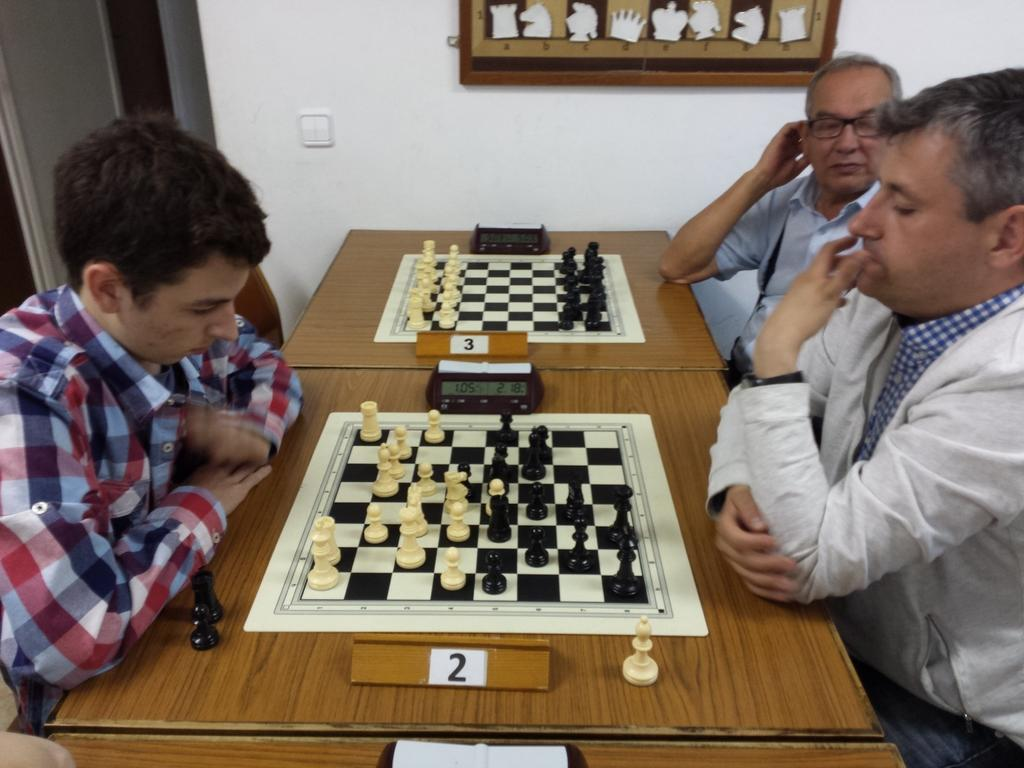How many people are in the image? There are three members in the image. What are the members doing in the image? Two of the members are playing chess, and they are sitting around two tables. Where is the chessboard located? The chessboard is placed on one of the tables. Can you describe anything in the background of the image? There is a photo frame in the background of the image, and it is attached to the wall. What type of joke is being told by the woman in the image? There are no women present in the image, and no one is telling a joke. How much pain is the person experiencing in the image? There is no indication of pain or discomfort in the image. 